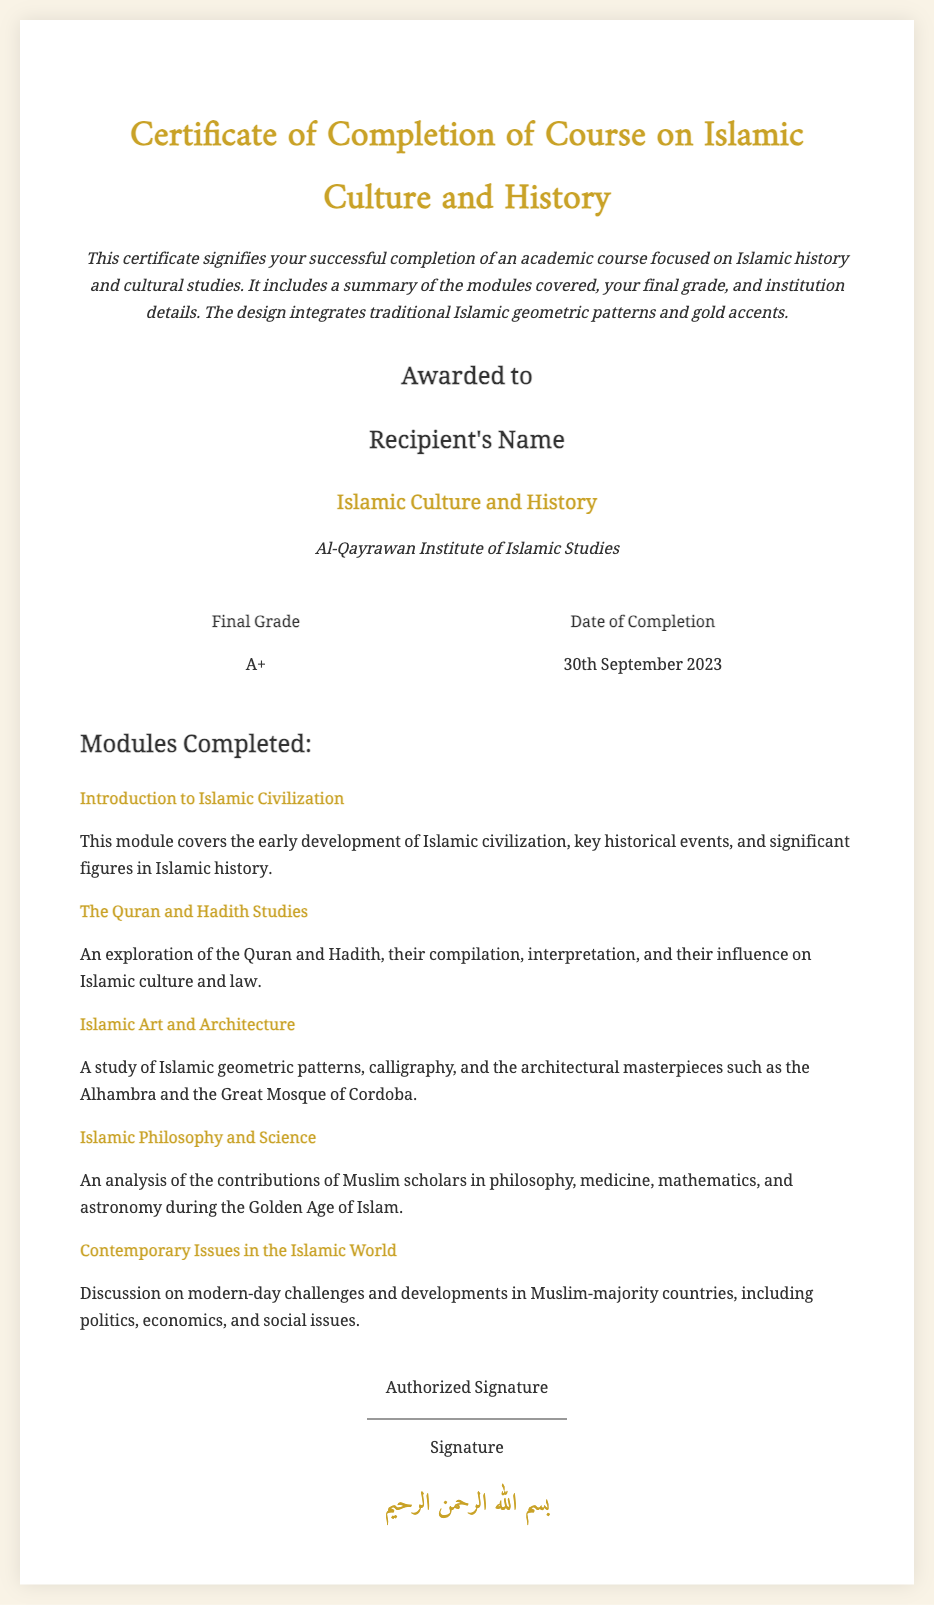What is the title of the course? The title of the course is specified at the top of the certificate.
Answer: Islamic Culture and History Who is the recipient of the certificate? The recipient's name is indicated below the phrase "Awarded to".
Answer: Recipient's Name What is the final grade received? The final grade is displayed in the grade section of the document.
Answer: A+ When was the course completed? The date of completion is noted in the section that includes the final grade.
Answer: 30th September 2023 What institution awarded the certificate? The institution's name is mentioned in the course details section.
Answer: Al-Qayrawan Institute of Islamic Studies How many modules are completed according to the certificate? The count of modules completed is outlined in the section listing the modules.
Answer: Five What is the focus of the module titled "Islamic Art and Architecture"? The content of this module is described in the corresponding section.
Answer: Study of Islamic geometric patterns and calligraphy What Arabic phrase is included at the bottom? The Arabic phrase is provided at the end of the certificate, showcasing cultural significance.
Answer: بسم الله الرحمن الرحيم What type of design elements are incorporated into the certificate? The document mentions the design aspects in the introductory description.
Answer: Traditional Islamic geometric patterns and gold accents 